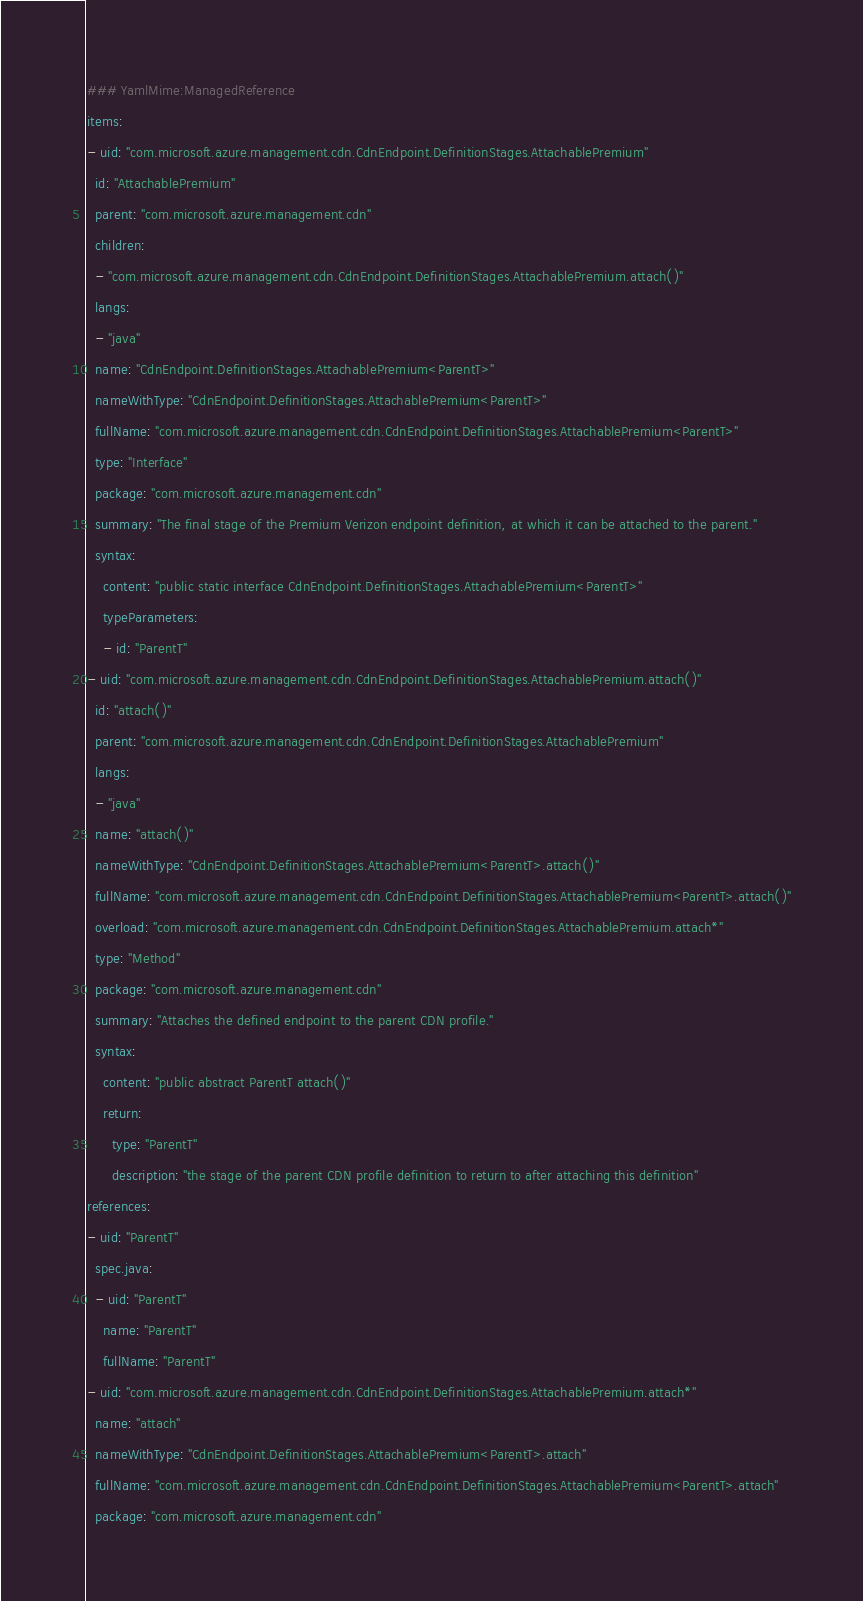Convert code to text. <code><loc_0><loc_0><loc_500><loc_500><_YAML_>### YamlMime:ManagedReference
items:
- uid: "com.microsoft.azure.management.cdn.CdnEndpoint.DefinitionStages.AttachablePremium"
  id: "AttachablePremium"
  parent: "com.microsoft.azure.management.cdn"
  children:
  - "com.microsoft.azure.management.cdn.CdnEndpoint.DefinitionStages.AttachablePremium.attach()"
  langs:
  - "java"
  name: "CdnEndpoint.DefinitionStages.AttachablePremium<ParentT>"
  nameWithType: "CdnEndpoint.DefinitionStages.AttachablePremium<ParentT>"
  fullName: "com.microsoft.azure.management.cdn.CdnEndpoint.DefinitionStages.AttachablePremium<ParentT>"
  type: "Interface"
  package: "com.microsoft.azure.management.cdn"
  summary: "The final stage of the Premium Verizon endpoint definition, at which it can be attached to the parent."
  syntax:
    content: "public static interface CdnEndpoint.DefinitionStages.AttachablePremium<ParentT>"
    typeParameters:
    - id: "ParentT"
- uid: "com.microsoft.azure.management.cdn.CdnEndpoint.DefinitionStages.AttachablePremium.attach()"
  id: "attach()"
  parent: "com.microsoft.azure.management.cdn.CdnEndpoint.DefinitionStages.AttachablePremium"
  langs:
  - "java"
  name: "attach()"
  nameWithType: "CdnEndpoint.DefinitionStages.AttachablePremium<ParentT>.attach()"
  fullName: "com.microsoft.azure.management.cdn.CdnEndpoint.DefinitionStages.AttachablePremium<ParentT>.attach()"
  overload: "com.microsoft.azure.management.cdn.CdnEndpoint.DefinitionStages.AttachablePremium.attach*"
  type: "Method"
  package: "com.microsoft.azure.management.cdn"
  summary: "Attaches the defined endpoint to the parent CDN profile."
  syntax:
    content: "public abstract ParentT attach()"
    return:
      type: "ParentT"
      description: "the stage of the parent CDN profile definition to return to after attaching this definition"
references:
- uid: "ParentT"
  spec.java:
  - uid: "ParentT"
    name: "ParentT"
    fullName: "ParentT"
- uid: "com.microsoft.azure.management.cdn.CdnEndpoint.DefinitionStages.AttachablePremium.attach*"
  name: "attach"
  nameWithType: "CdnEndpoint.DefinitionStages.AttachablePremium<ParentT>.attach"
  fullName: "com.microsoft.azure.management.cdn.CdnEndpoint.DefinitionStages.AttachablePremium<ParentT>.attach"
  package: "com.microsoft.azure.management.cdn"
</code> 